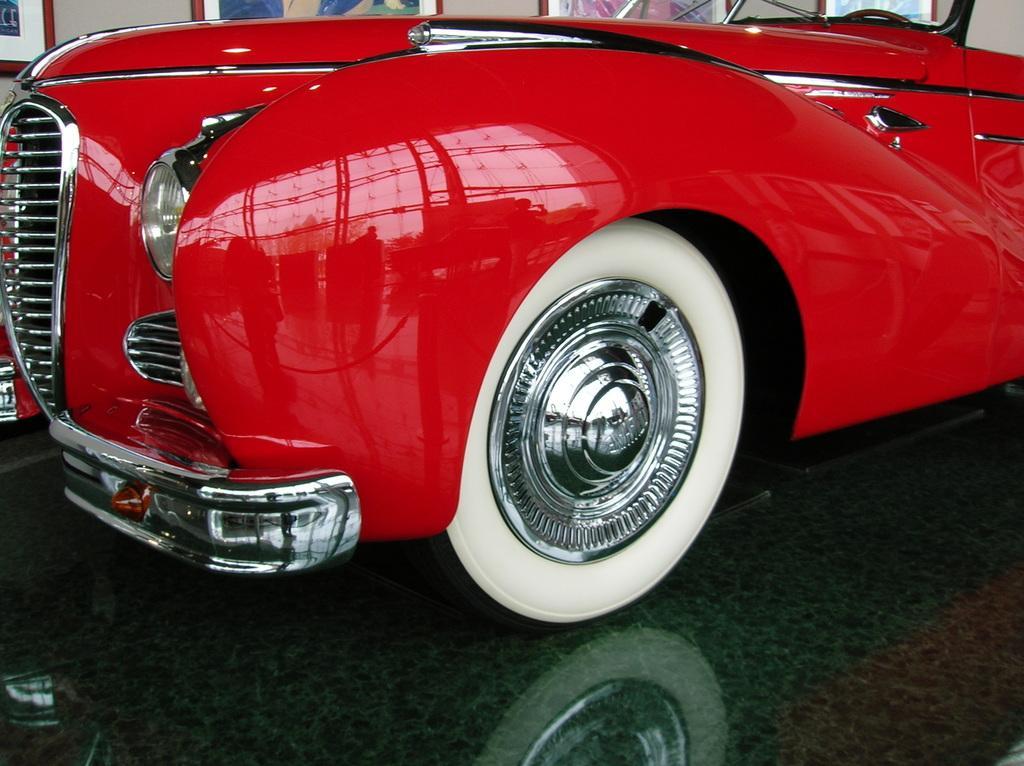In one or two sentences, can you explain what this image depicts? In this picture there is a red color vehicle which has a white color tire to it and there are few photo frames attached to the wall in the background. 